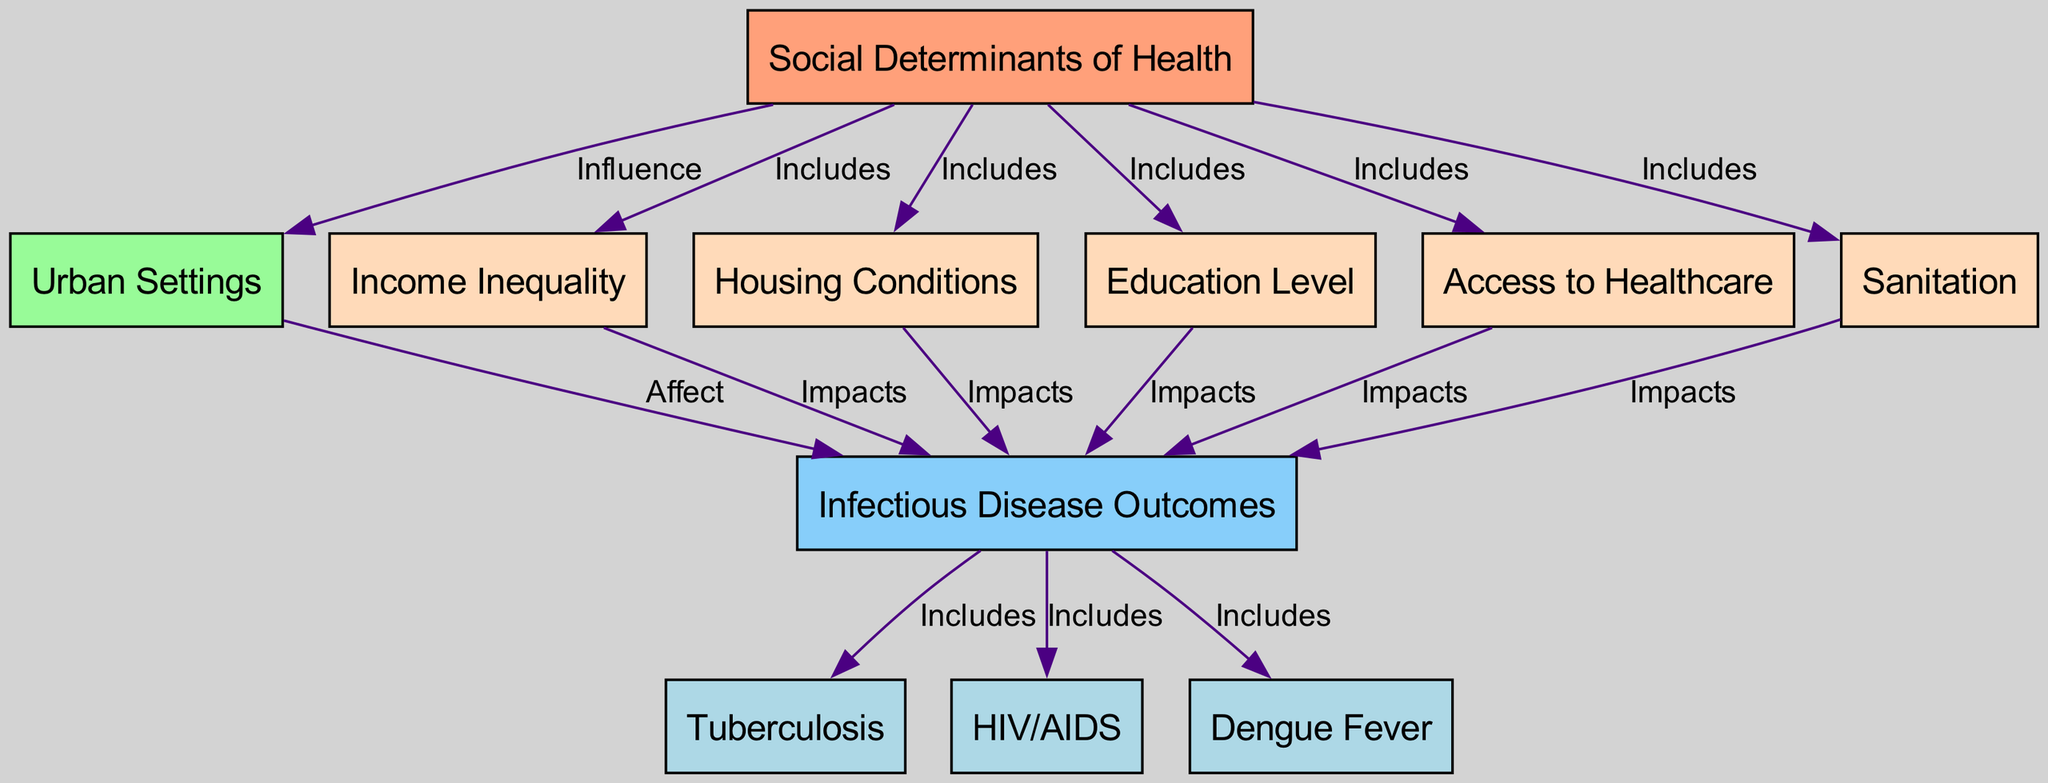What is the main theme of the diagram? The main theme is represented by the first node labeled "Social Determinants of Health," indicating that the diagram explores how various social factors influence health outcomes.
Answer: Social Determinants of Health How many nodes are present in the diagram? By counting all unique nodes listed, we find that there are 11 nodes in total within the diagram.
Answer: 11 What type of relationship connects "Social Determinants of Health" to "Urban Settings"? The relationship is defined as "Influence," indicating that social determinants have an impactful role on urban settings.
Answer: Influence Which factors are considered to impact "Infectious Disease Outcomes"? Factors impacting infectious disease outcomes include "Income Inequality," "Housing Conditions," "Education Level," "Access to Healthcare," and "Sanitation," as shown by their connections in the diagram.
Answer: Income Inequality, Housing Conditions, Education Level, Access to Healthcare, Sanitation What infectious diseases are included in the outcomes? The diseases included are "Tuberculosis," "HIV/AIDS," and "Dengue Fever," directly linked to the "Infectious Disease Outcomes" node.
Answer: Tuberculosis, HIV/AIDS, Dengue Fever If housing conditions improve, what is the expected outcome? Improvement in housing conditions would likely lead to better health outcomes regarding infectious diseases, as indicated by the arrow showing that "Housing Conditions" impacts "Infectious Disease Outcomes."
Answer: Better health outcomes Which node connects to the most edges in terms of influencing health outcomes? "Social Determinants of Health" connects to five edges, indicating multiple influences on urban settings and their health outcomes.
Answer: Social Determinants of Health What does "Access to Healthcare" directly impact? The node "Access to Healthcare" directly impacts "Infectious Disease Outcomes," signifying that increased access affects health results.
Answer: Infectious Disease Outcomes How do urban settings relate to social determinants of health? Urban settings are influenced by social determinants of health, as depicted by the directed edge leading from "Social Determinants of Health" to "Urban Settings."
Answer: Influence 